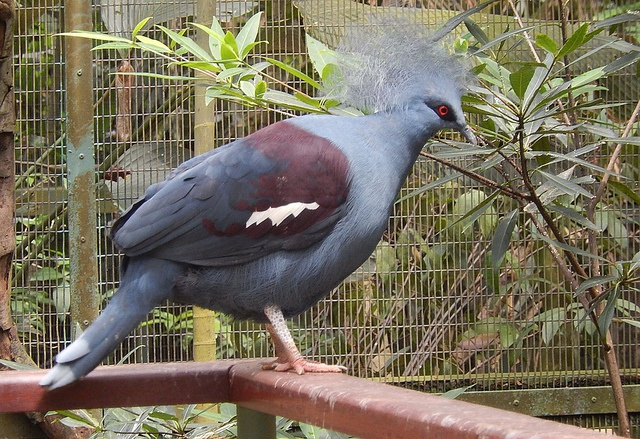Describe the objects in this image and their specific colors. I can see a bird in black, gray, and darkgray tones in this image. 